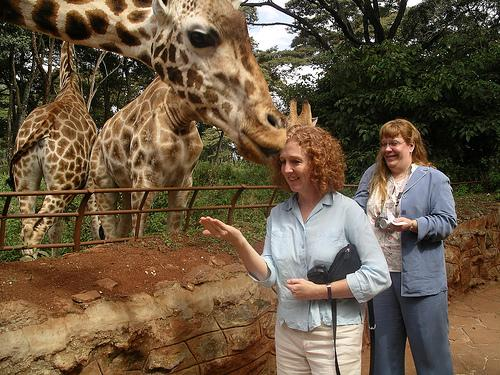Question: how many women?
Choices:
A. Three.
B. One.
C. Two.
D. None.
Answer with the letter. Answer: C Question: what is the curly haired woman doing with her hand?
Choices:
A. Massaging it.
B. Counting her fingers.
C. Washing it.
D. Raising it.
Answer with the letter. Answer: D Question: what color is the curly headed woman's shirt?
Choices:
A. Yellow.
B. White.
C. Blue.
D. Black.
Answer with the letter. Answer: C Question: who is holding a camera?
Choices:
A. Man in car.
B. Boy on bicycle.
C. Girl at front.
D. Woman in back.
Answer with the letter. Answer: D Question: how many animals?
Choices:
A. Four.
B. Six.
C. Three.
D. Five.
Answer with the letter. Answer: C Question: what color are the leaves?
Choices:
A. Green.
B. Red.
C. Brown.
D. Tan.
Answer with the letter. Answer: A 